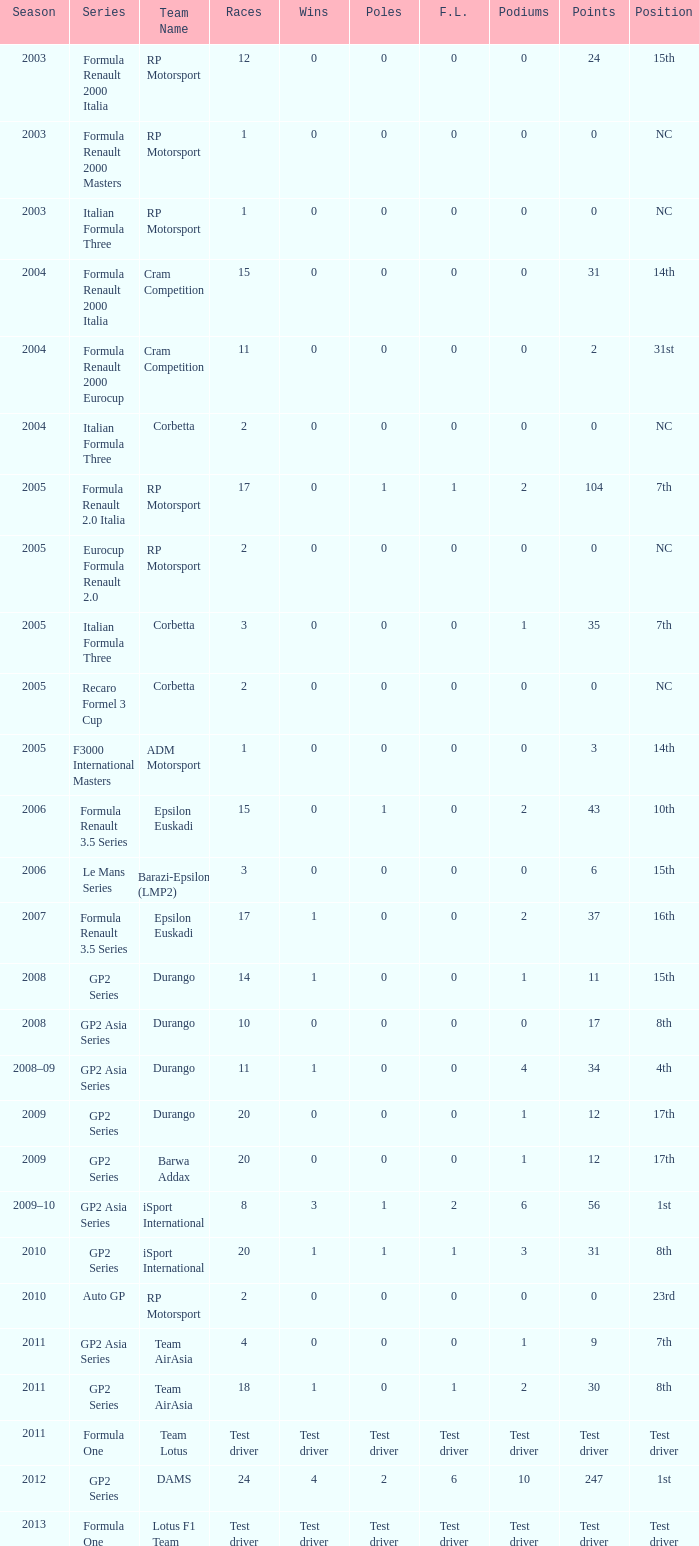What is the count of podiums with 0 victories and 6 points? 0.0. 